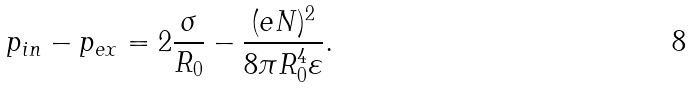Convert formula to latex. <formula><loc_0><loc_0><loc_500><loc_500>p _ { i n } - p _ { e x } = 2 \frac { \sigma } { R _ { 0 } } - \frac { ( e N ) ^ { 2 } } { 8 \pi R _ { 0 } ^ { 4 } \varepsilon } .</formula> 